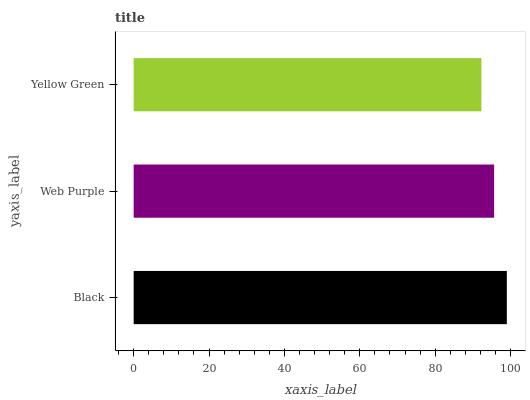Is Yellow Green the minimum?
Answer yes or no. Yes. Is Black the maximum?
Answer yes or no. Yes. Is Web Purple the minimum?
Answer yes or no. No. Is Web Purple the maximum?
Answer yes or no. No. Is Black greater than Web Purple?
Answer yes or no. Yes. Is Web Purple less than Black?
Answer yes or no. Yes. Is Web Purple greater than Black?
Answer yes or no. No. Is Black less than Web Purple?
Answer yes or no. No. Is Web Purple the high median?
Answer yes or no. Yes. Is Web Purple the low median?
Answer yes or no. Yes. Is Black the high median?
Answer yes or no. No. Is Black the low median?
Answer yes or no. No. 